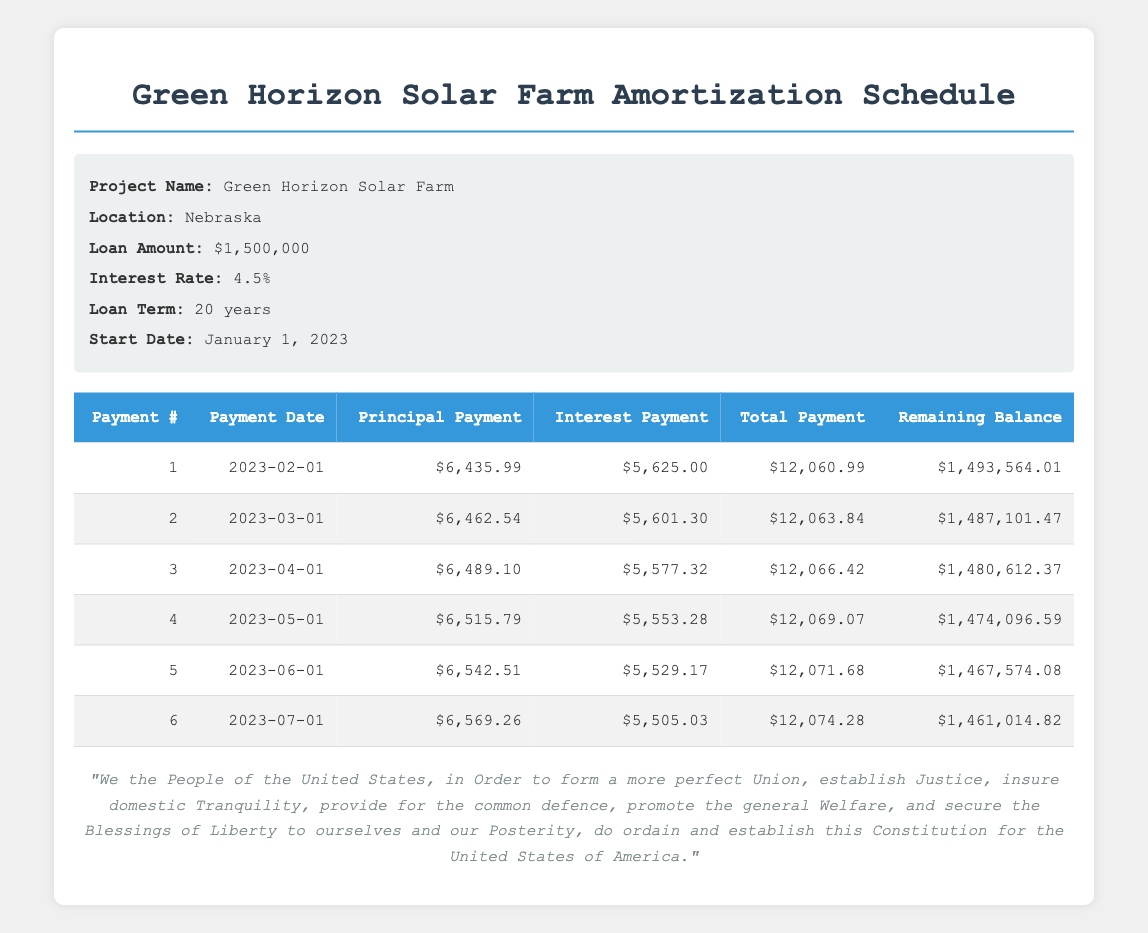What is the total payment due for the first month? The total payment for the first month is presented in the table under the "Total Payment" column for payment number 1, which is 12060.99.
Answer: 12060.99 What is the interest payment for the second month? The interest payment for the second month can be found in the "Interest Payment" column for payment number 2, which is 5601.30.
Answer: 5601.30 How much is the total principal paid off after the first three months? To find the total principal paid off after the first three months, we add the principal payments from the first three months: 6435.99 + 6462.54 + 6489.10 = 19387.63.
Answer: 19387.63 Is the interest payment decreasing each month? The interest payment for each subsequent month is less than the previous month. The values for the first three months are 5625.00, 5601.30, and 5577.32, which confirms that the interest payment is decreasing.
Answer: Yes What is the remaining balance after the sixth payment? The remaining balance after the sixth payment is listed in the "Remaining Balance" column for payment number 6, which is 1461014.82.
Answer: 1461014.82 What is the average principal payment over the first six months? To find the average principal payment over the first six months, we first sum the principal payments: 6435.99 + 6462.54 + 6489.10 + 6515.79 + 6542.51 + 6569.26 = 39014.19. Then, we divide by 6 (the number of months): 39014.19 / 6 = 6502.36.
Answer: 6502.36 How much total has been paid towards the principal after the fifth payment? To calculate the total principal paid after the fifth payment, we sum the principal payments for the first five months: 6435.99 + 6462.54 + 6489.10 + 6515.79 + 6542.51 = 32445.93.
Answer: 32445.93 What is the common trend in the principal payments from month to month? The principal payments are gradually increasing from month to month as observed in the "Principal Payment" column. The values range from 6435.99 to 6569.26, indicating an increasing trend.
Answer: Increasing 